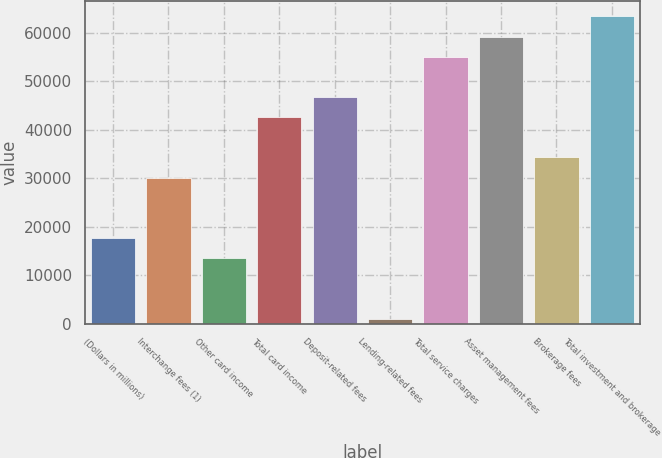Convert chart to OTSL. <chart><loc_0><loc_0><loc_500><loc_500><bar_chart><fcel>(Dollars in millions)<fcel>Interchange fees (1)<fcel>Other card income<fcel>Total card income<fcel>Deposit-related fees<fcel>Lending-related fees<fcel>Total service charges<fcel>Asset management fees<fcel>Brokerage fees<fcel>Total investment and brokerage<nl><fcel>17697.8<fcel>30151.4<fcel>13546.6<fcel>42605<fcel>46756.2<fcel>1093<fcel>55058.6<fcel>59209.8<fcel>34302.6<fcel>63361<nl></chart> 